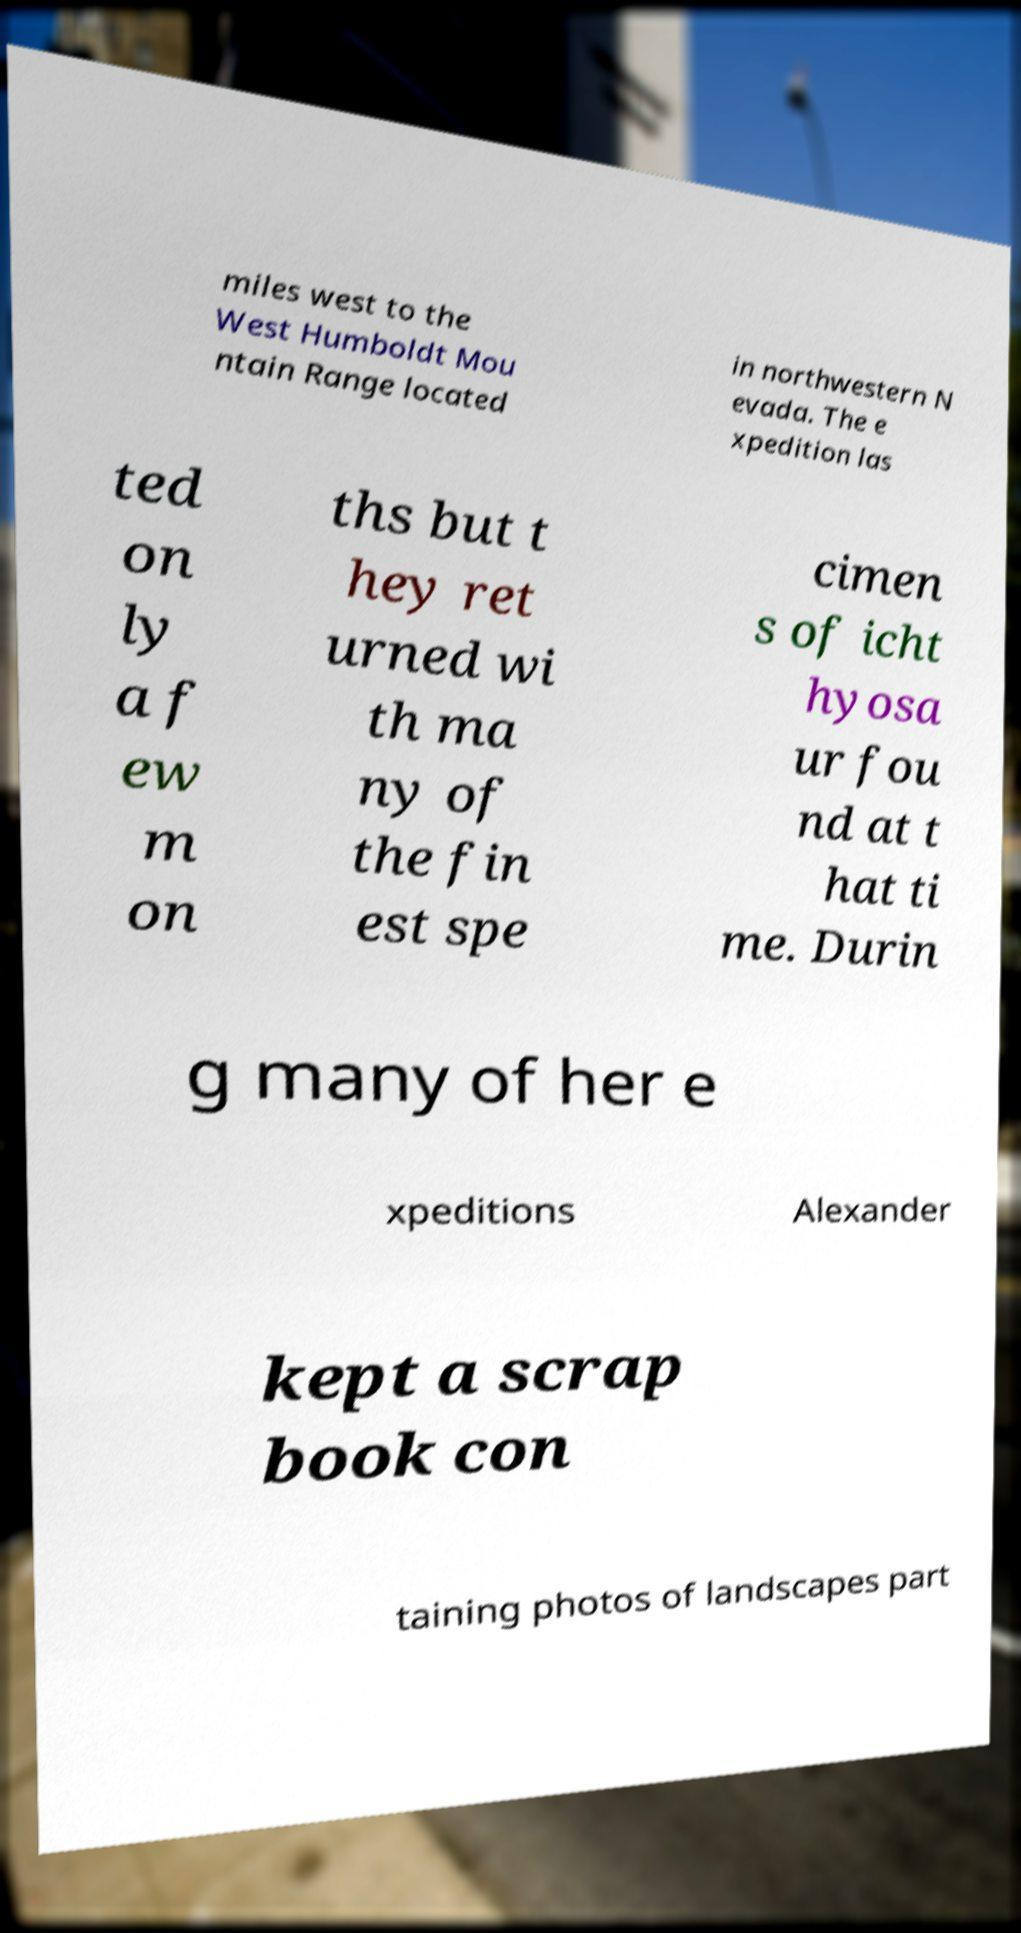Please identify and transcribe the text found in this image. miles west to the West Humboldt Mou ntain Range located in northwestern N evada. The e xpedition las ted on ly a f ew m on ths but t hey ret urned wi th ma ny of the fin est spe cimen s of icht hyosa ur fou nd at t hat ti me. Durin g many of her e xpeditions Alexander kept a scrap book con taining photos of landscapes part 